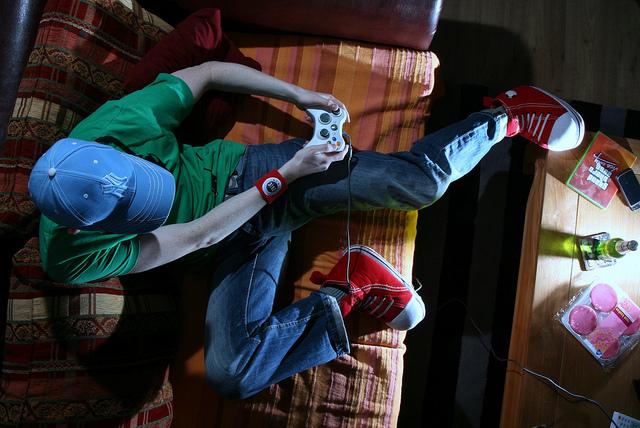Where is a Yankees baseball cap?
Concise answer only. Head. Is the teenager being active?
Be succinct. No. What are the color of his slippers?
Short answer required. Red and white. 